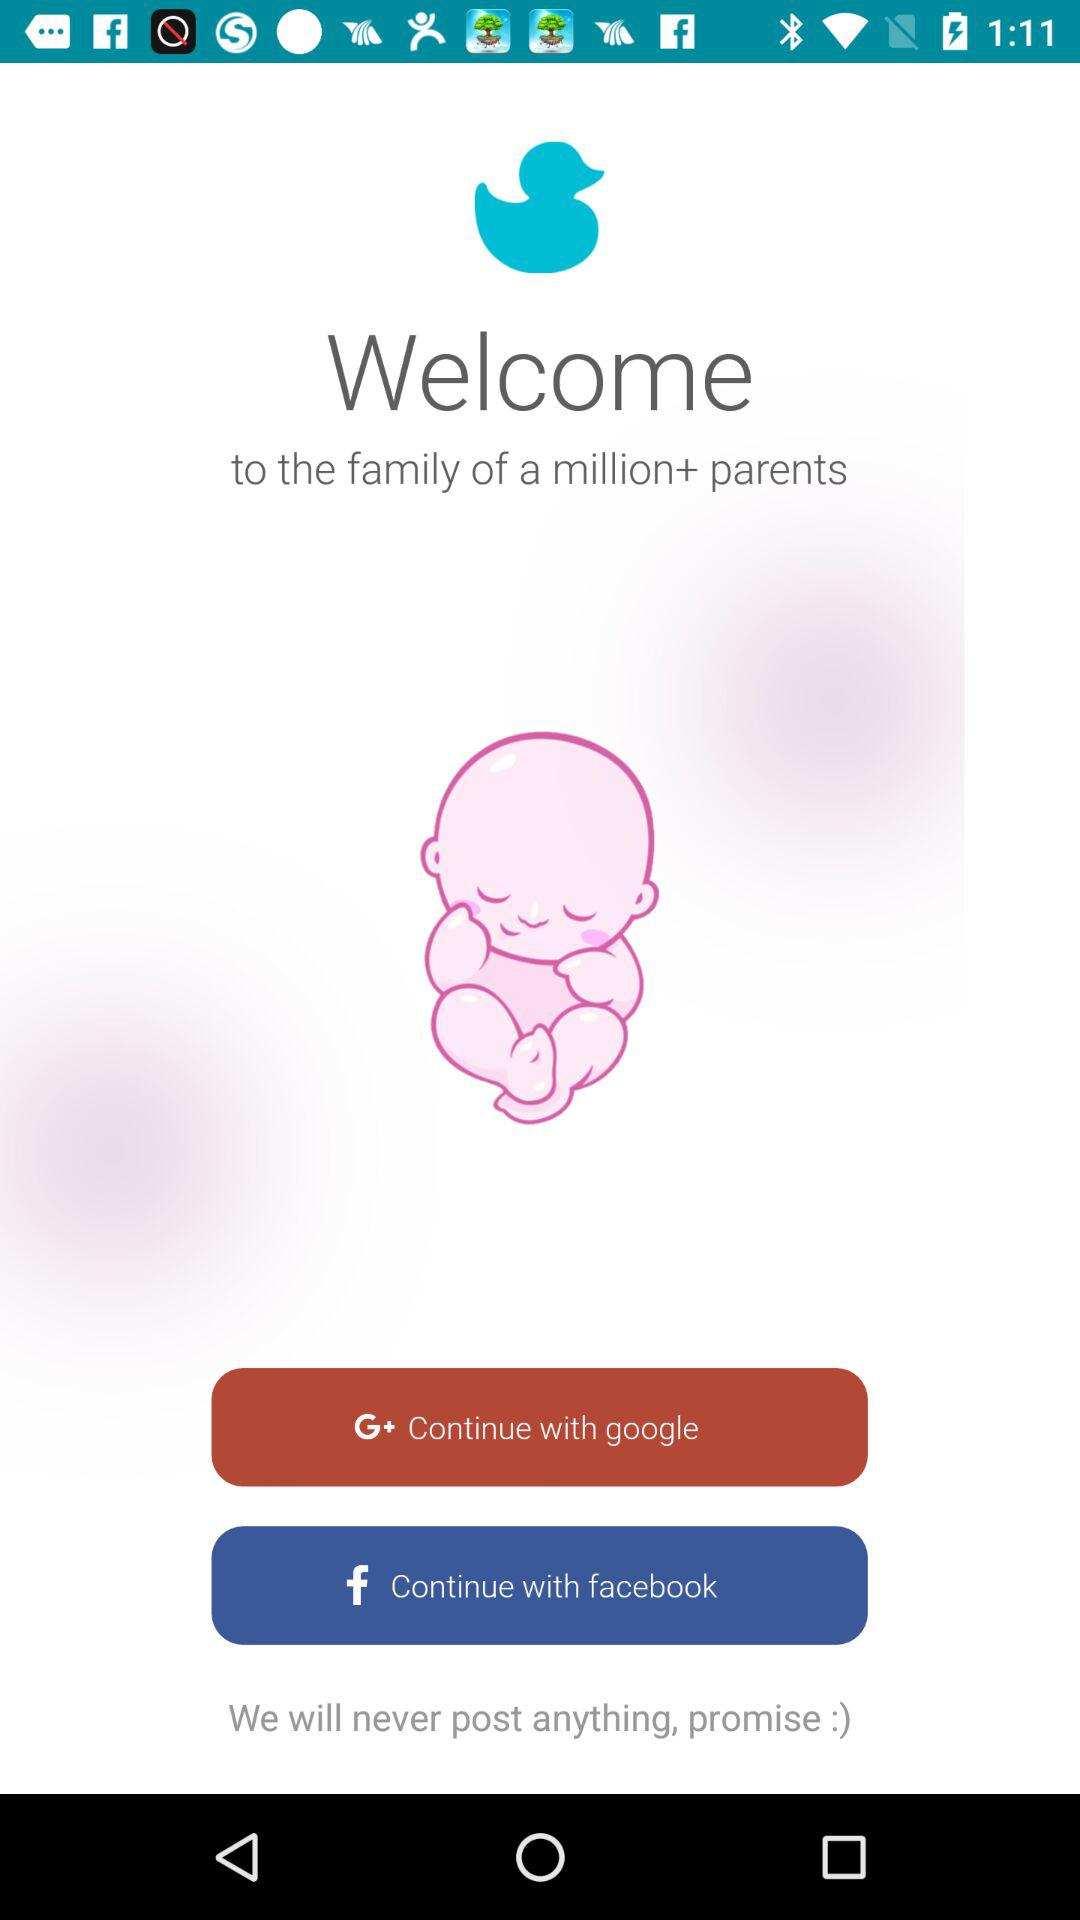With which application can it be shared? It can be shared with "google" and "facebook". 